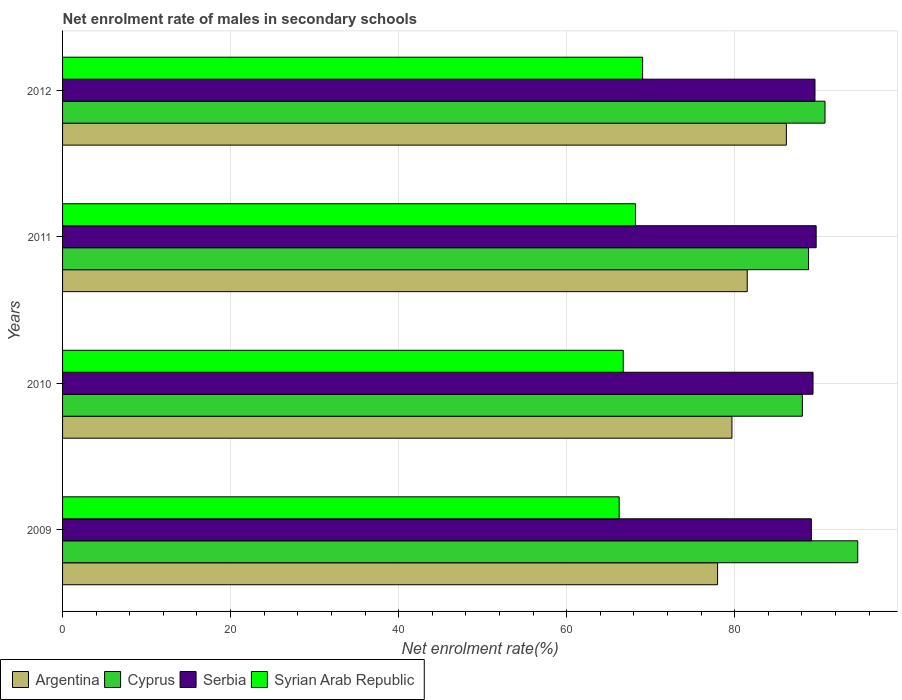Are the number of bars on each tick of the Y-axis equal?
Ensure brevity in your answer.  Yes. How many bars are there on the 1st tick from the top?
Offer a very short reply. 4. What is the net enrolment rate of males in secondary schools in Syrian Arab Republic in 2011?
Offer a terse response. 68.2. Across all years, what is the maximum net enrolment rate of males in secondary schools in Serbia?
Offer a terse response. 89.7. Across all years, what is the minimum net enrolment rate of males in secondary schools in Serbia?
Offer a terse response. 89.12. In which year was the net enrolment rate of males in secondary schools in Syrian Arab Republic maximum?
Ensure brevity in your answer.  2012. What is the total net enrolment rate of males in secondary schools in Syrian Arab Republic in the graph?
Offer a terse response. 270.22. What is the difference between the net enrolment rate of males in secondary schools in Argentina in 2011 and that in 2012?
Give a very brief answer. -4.66. What is the difference between the net enrolment rate of males in secondary schools in Cyprus in 2010 and the net enrolment rate of males in secondary schools in Serbia in 2009?
Give a very brief answer. -1.07. What is the average net enrolment rate of males in secondary schools in Cyprus per year?
Ensure brevity in your answer.  90.56. In the year 2009, what is the difference between the net enrolment rate of males in secondary schools in Argentina and net enrolment rate of males in secondary schools in Syrian Arab Republic?
Provide a succinct answer. 11.72. In how many years, is the net enrolment rate of males in secondary schools in Syrian Arab Republic greater than 84 %?
Your answer should be very brief. 0. What is the ratio of the net enrolment rate of males in secondary schools in Syrian Arab Republic in 2010 to that in 2011?
Provide a short and direct response. 0.98. Is the net enrolment rate of males in secondary schools in Cyprus in 2010 less than that in 2011?
Your response must be concise. Yes. What is the difference between the highest and the second highest net enrolment rate of males in secondary schools in Argentina?
Give a very brief answer. 4.66. What is the difference between the highest and the lowest net enrolment rate of males in secondary schools in Serbia?
Give a very brief answer. 0.57. Is the sum of the net enrolment rate of males in secondary schools in Serbia in 2009 and 2011 greater than the maximum net enrolment rate of males in secondary schools in Argentina across all years?
Keep it short and to the point. Yes. Is it the case that in every year, the sum of the net enrolment rate of males in secondary schools in Syrian Arab Republic and net enrolment rate of males in secondary schools in Cyprus is greater than the sum of net enrolment rate of males in secondary schools in Argentina and net enrolment rate of males in secondary schools in Serbia?
Your response must be concise. Yes. What does the 4th bar from the top in 2010 represents?
Make the answer very short. Argentina. What does the 1st bar from the bottom in 2011 represents?
Keep it short and to the point. Argentina. Is it the case that in every year, the sum of the net enrolment rate of males in secondary schools in Serbia and net enrolment rate of males in secondary schools in Syrian Arab Republic is greater than the net enrolment rate of males in secondary schools in Argentina?
Your answer should be compact. Yes. How many years are there in the graph?
Provide a short and direct response. 4. What is the difference between two consecutive major ticks on the X-axis?
Your answer should be compact. 20. Does the graph contain any zero values?
Ensure brevity in your answer.  No. Does the graph contain grids?
Keep it short and to the point. Yes. Where does the legend appear in the graph?
Your answer should be very brief. Bottom left. What is the title of the graph?
Offer a very short reply. Net enrolment rate of males in secondary schools. Does "France" appear as one of the legend labels in the graph?
Provide a succinct answer. No. What is the label or title of the X-axis?
Keep it short and to the point. Net enrolment rate(%). What is the label or title of the Y-axis?
Your response must be concise. Years. What is the Net enrolment rate(%) of Argentina in 2009?
Your answer should be very brief. 77.97. What is the Net enrolment rate(%) in Cyprus in 2009?
Keep it short and to the point. 94.65. What is the Net enrolment rate(%) of Serbia in 2009?
Your response must be concise. 89.12. What is the Net enrolment rate(%) of Syrian Arab Republic in 2009?
Your response must be concise. 66.25. What is the Net enrolment rate(%) of Argentina in 2010?
Your answer should be compact. 79.67. What is the Net enrolment rate(%) in Cyprus in 2010?
Keep it short and to the point. 88.05. What is the Net enrolment rate(%) of Serbia in 2010?
Keep it short and to the point. 89.32. What is the Net enrolment rate(%) of Syrian Arab Republic in 2010?
Offer a terse response. 66.74. What is the Net enrolment rate(%) in Argentina in 2011?
Offer a terse response. 81.49. What is the Net enrolment rate(%) of Cyprus in 2011?
Make the answer very short. 88.79. What is the Net enrolment rate(%) in Serbia in 2011?
Provide a succinct answer. 89.7. What is the Net enrolment rate(%) of Syrian Arab Republic in 2011?
Offer a very short reply. 68.2. What is the Net enrolment rate(%) in Argentina in 2012?
Your answer should be very brief. 86.15. What is the Net enrolment rate(%) in Cyprus in 2012?
Your response must be concise. 90.75. What is the Net enrolment rate(%) in Serbia in 2012?
Offer a terse response. 89.56. What is the Net enrolment rate(%) in Syrian Arab Republic in 2012?
Your response must be concise. 69.04. Across all years, what is the maximum Net enrolment rate(%) of Argentina?
Offer a terse response. 86.15. Across all years, what is the maximum Net enrolment rate(%) in Cyprus?
Ensure brevity in your answer.  94.65. Across all years, what is the maximum Net enrolment rate(%) in Serbia?
Provide a short and direct response. 89.7. Across all years, what is the maximum Net enrolment rate(%) in Syrian Arab Republic?
Offer a very short reply. 69.04. Across all years, what is the minimum Net enrolment rate(%) in Argentina?
Keep it short and to the point. 77.97. Across all years, what is the minimum Net enrolment rate(%) in Cyprus?
Offer a very short reply. 88.05. Across all years, what is the minimum Net enrolment rate(%) in Serbia?
Your answer should be very brief. 89.12. Across all years, what is the minimum Net enrolment rate(%) of Syrian Arab Republic?
Offer a very short reply. 66.25. What is the total Net enrolment rate(%) in Argentina in the graph?
Offer a terse response. 325.28. What is the total Net enrolment rate(%) in Cyprus in the graph?
Keep it short and to the point. 362.24. What is the total Net enrolment rate(%) in Serbia in the graph?
Make the answer very short. 357.7. What is the total Net enrolment rate(%) of Syrian Arab Republic in the graph?
Offer a very short reply. 270.22. What is the difference between the Net enrolment rate(%) in Argentina in 2009 and that in 2010?
Your response must be concise. -1.71. What is the difference between the Net enrolment rate(%) of Cyprus in 2009 and that in 2010?
Offer a terse response. 6.59. What is the difference between the Net enrolment rate(%) of Serbia in 2009 and that in 2010?
Your answer should be compact. -0.2. What is the difference between the Net enrolment rate(%) of Syrian Arab Republic in 2009 and that in 2010?
Your answer should be very brief. -0.49. What is the difference between the Net enrolment rate(%) in Argentina in 2009 and that in 2011?
Make the answer very short. -3.53. What is the difference between the Net enrolment rate(%) of Cyprus in 2009 and that in 2011?
Your response must be concise. 5.85. What is the difference between the Net enrolment rate(%) in Serbia in 2009 and that in 2011?
Provide a short and direct response. -0.57. What is the difference between the Net enrolment rate(%) in Syrian Arab Republic in 2009 and that in 2011?
Your answer should be very brief. -1.95. What is the difference between the Net enrolment rate(%) of Argentina in 2009 and that in 2012?
Offer a terse response. -8.19. What is the difference between the Net enrolment rate(%) of Cyprus in 2009 and that in 2012?
Your answer should be compact. 3.9. What is the difference between the Net enrolment rate(%) in Serbia in 2009 and that in 2012?
Offer a very short reply. -0.43. What is the difference between the Net enrolment rate(%) in Syrian Arab Republic in 2009 and that in 2012?
Provide a short and direct response. -2.79. What is the difference between the Net enrolment rate(%) of Argentina in 2010 and that in 2011?
Provide a short and direct response. -1.82. What is the difference between the Net enrolment rate(%) of Cyprus in 2010 and that in 2011?
Make the answer very short. -0.74. What is the difference between the Net enrolment rate(%) of Serbia in 2010 and that in 2011?
Your answer should be compact. -0.37. What is the difference between the Net enrolment rate(%) in Syrian Arab Republic in 2010 and that in 2011?
Your answer should be very brief. -1.46. What is the difference between the Net enrolment rate(%) of Argentina in 2010 and that in 2012?
Provide a short and direct response. -6.48. What is the difference between the Net enrolment rate(%) of Cyprus in 2010 and that in 2012?
Your response must be concise. -2.7. What is the difference between the Net enrolment rate(%) of Serbia in 2010 and that in 2012?
Your answer should be compact. -0.23. What is the difference between the Net enrolment rate(%) in Syrian Arab Republic in 2010 and that in 2012?
Your response must be concise. -2.3. What is the difference between the Net enrolment rate(%) in Argentina in 2011 and that in 2012?
Your answer should be very brief. -4.66. What is the difference between the Net enrolment rate(%) in Cyprus in 2011 and that in 2012?
Provide a succinct answer. -1.96. What is the difference between the Net enrolment rate(%) of Serbia in 2011 and that in 2012?
Make the answer very short. 0.14. What is the difference between the Net enrolment rate(%) in Syrian Arab Republic in 2011 and that in 2012?
Your response must be concise. -0.84. What is the difference between the Net enrolment rate(%) in Argentina in 2009 and the Net enrolment rate(%) in Cyprus in 2010?
Offer a very short reply. -10.09. What is the difference between the Net enrolment rate(%) in Argentina in 2009 and the Net enrolment rate(%) in Serbia in 2010?
Keep it short and to the point. -11.36. What is the difference between the Net enrolment rate(%) in Argentina in 2009 and the Net enrolment rate(%) in Syrian Arab Republic in 2010?
Give a very brief answer. 11.23. What is the difference between the Net enrolment rate(%) in Cyprus in 2009 and the Net enrolment rate(%) in Serbia in 2010?
Your answer should be very brief. 5.32. What is the difference between the Net enrolment rate(%) of Cyprus in 2009 and the Net enrolment rate(%) of Syrian Arab Republic in 2010?
Provide a short and direct response. 27.91. What is the difference between the Net enrolment rate(%) of Serbia in 2009 and the Net enrolment rate(%) of Syrian Arab Republic in 2010?
Ensure brevity in your answer.  22.39. What is the difference between the Net enrolment rate(%) in Argentina in 2009 and the Net enrolment rate(%) in Cyprus in 2011?
Ensure brevity in your answer.  -10.83. What is the difference between the Net enrolment rate(%) of Argentina in 2009 and the Net enrolment rate(%) of Serbia in 2011?
Provide a succinct answer. -11.73. What is the difference between the Net enrolment rate(%) of Argentina in 2009 and the Net enrolment rate(%) of Syrian Arab Republic in 2011?
Provide a succinct answer. 9.77. What is the difference between the Net enrolment rate(%) in Cyprus in 2009 and the Net enrolment rate(%) in Serbia in 2011?
Ensure brevity in your answer.  4.95. What is the difference between the Net enrolment rate(%) of Cyprus in 2009 and the Net enrolment rate(%) of Syrian Arab Republic in 2011?
Offer a terse response. 26.45. What is the difference between the Net enrolment rate(%) in Serbia in 2009 and the Net enrolment rate(%) in Syrian Arab Republic in 2011?
Offer a very short reply. 20.93. What is the difference between the Net enrolment rate(%) in Argentina in 2009 and the Net enrolment rate(%) in Cyprus in 2012?
Give a very brief answer. -12.78. What is the difference between the Net enrolment rate(%) of Argentina in 2009 and the Net enrolment rate(%) of Serbia in 2012?
Your answer should be very brief. -11.59. What is the difference between the Net enrolment rate(%) in Argentina in 2009 and the Net enrolment rate(%) in Syrian Arab Republic in 2012?
Provide a short and direct response. 8.92. What is the difference between the Net enrolment rate(%) in Cyprus in 2009 and the Net enrolment rate(%) in Serbia in 2012?
Keep it short and to the point. 5.09. What is the difference between the Net enrolment rate(%) of Cyprus in 2009 and the Net enrolment rate(%) of Syrian Arab Republic in 2012?
Provide a short and direct response. 25.6. What is the difference between the Net enrolment rate(%) in Serbia in 2009 and the Net enrolment rate(%) in Syrian Arab Republic in 2012?
Give a very brief answer. 20.08. What is the difference between the Net enrolment rate(%) of Argentina in 2010 and the Net enrolment rate(%) of Cyprus in 2011?
Offer a very short reply. -9.12. What is the difference between the Net enrolment rate(%) of Argentina in 2010 and the Net enrolment rate(%) of Serbia in 2011?
Ensure brevity in your answer.  -10.03. What is the difference between the Net enrolment rate(%) of Argentina in 2010 and the Net enrolment rate(%) of Syrian Arab Republic in 2011?
Offer a terse response. 11.47. What is the difference between the Net enrolment rate(%) in Cyprus in 2010 and the Net enrolment rate(%) in Serbia in 2011?
Give a very brief answer. -1.64. What is the difference between the Net enrolment rate(%) of Cyprus in 2010 and the Net enrolment rate(%) of Syrian Arab Republic in 2011?
Keep it short and to the point. 19.86. What is the difference between the Net enrolment rate(%) in Serbia in 2010 and the Net enrolment rate(%) in Syrian Arab Republic in 2011?
Keep it short and to the point. 21.13. What is the difference between the Net enrolment rate(%) in Argentina in 2010 and the Net enrolment rate(%) in Cyprus in 2012?
Provide a short and direct response. -11.08. What is the difference between the Net enrolment rate(%) in Argentina in 2010 and the Net enrolment rate(%) in Serbia in 2012?
Ensure brevity in your answer.  -9.89. What is the difference between the Net enrolment rate(%) of Argentina in 2010 and the Net enrolment rate(%) of Syrian Arab Republic in 2012?
Ensure brevity in your answer.  10.63. What is the difference between the Net enrolment rate(%) of Cyprus in 2010 and the Net enrolment rate(%) of Serbia in 2012?
Make the answer very short. -1.5. What is the difference between the Net enrolment rate(%) of Cyprus in 2010 and the Net enrolment rate(%) of Syrian Arab Republic in 2012?
Offer a very short reply. 19.01. What is the difference between the Net enrolment rate(%) in Serbia in 2010 and the Net enrolment rate(%) in Syrian Arab Republic in 2012?
Make the answer very short. 20.28. What is the difference between the Net enrolment rate(%) of Argentina in 2011 and the Net enrolment rate(%) of Cyprus in 2012?
Keep it short and to the point. -9.26. What is the difference between the Net enrolment rate(%) of Argentina in 2011 and the Net enrolment rate(%) of Serbia in 2012?
Your response must be concise. -8.06. What is the difference between the Net enrolment rate(%) in Argentina in 2011 and the Net enrolment rate(%) in Syrian Arab Republic in 2012?
Keep it short and to the point. 12.45. What is the difference between the Net enrolment rate(%) in Cyprus in 2011 and the Net enrolment rate(%) in Serbia in 2012?
Your response must be concise. -0.77. What is the difference between the Net enrolment rate(%) in Cyprus in 2011 and the Net enrolment rate(%) in Syrian Arab Republic in 2012?
Give a very brief answer. 19.75. What is the difference between the Net enrolment rate(%) of Serbia in 2011 and the Net enrolment rate(%) of Syrian Arab Republic in 2012?
Your answer should be compact. 20.66. What is the average Net enrolment rate(%) in Argentina per year?
Make the answer very short. 81.32. What is the average Net enrolment rate(%) in Cyprus per year?
Give a very brief answer. 90.56. What is the average Net enrolment rate(%) of Serbia per year?
Provide a succinct answer. 89.43. What is the average Net enrolment rate(%) in Syrian Arab Republic per year?
Offer a very short reply. 67.56. In the year 2009, what is the difference between the Net enrolment rate(%) of Argentina and Net enrolment rate(%) of Cyprus?
Your response must be concise. -16.68. In the year 2009, what is the difference between the Net enrolment rate(%) of Argentina and Net enrolment rate(%) of Serbia?
Keep it short and to the point. -11.16. In the year 2009, what is the difference between the Net enrolment rate(%) in Argentina and Net enrolment rate(%) in Syrian Arab Republic?
Ensure brevity in your answer.  11.72. In the year 2009, what is the difference between the Net enrolment rate(%) in Cyprus and Net enrolment rate(%) in Serbia?
Offer a very short reply. 5.52. In the year 2009, what is the difference between the Net enrolment rate(%) of Cyprus and Net enrolment rate(%) of Syrian Arab Republic?
Your answer should be very brief. 28.4. In the year 2009, what is the difference between the Net enrolment rate(%) in Serbia and Net enrolment rate(%) in Syrian Arab Republic?
Your answer should be compact. 22.87. In the year 2010, what is the difference between the Net enrolment rate(%) in Argentina and Net enrolment rate(%) in Cyprus?
Keep it short and to the point. -8.38. In the year 2010, what is the difference between the Net enrolment rate(%) of Argentina and Net enrolment rate(%) of Serbia?
Offer a very short reply. -9.65. In the year 2010, what is the difference between the Net enrolment rate(%) of Argentina and Net enrolment rate(%) of Syrian Arab Republic?
Provide a succinct answer. 12.94. In the year 2010, what is the difference between the Net enrolment rate(%) of Cyprus and Net enrolment rate(%) of Serbia?
Your answer should be compact. -1.27. In the year 2010, what is the difference between the Net enrolment rate(%) of Cyprus and Net enrolment rate(%) of Syrian Arab Republic?
Make the answer very short. 21.32. In the year 2010, what is the difference between the Net enrolment rate(%) of Serbia and Net enrolment rate(%) of Syrian Arab Republic?
Your answer should be compact. 22.59. In the year 2011, what is the difference between the Net enrolment rate(%) of Argentina and Net enrolment rate(%) of Cyprus?
Keep it short and to the point. -7.3. In the year 2011, what is the difference between the Net enrolment rate(%) in Argentina and Net enrolment rate(%) in Serbia?
Keep it short and to the point. -8.2. In the year 2011, what is the difference between the Net enrolment rate(%) in Argentina and Net enrolment rate(%) in Syrian Arab Republic?
Ensure brevity in your answer.  13.3. In the year 2011, what is the difference between the Net enrolment rate(%) of Cyprus and Net enrolment rate(%) of Serbia?
Provide a succinct answer. -0.91. In the year 2011, what is the difference between the Net enrolment rate(%) in Cyprus and Net enrolment rate(%) in Syrian Arab Republic?
Provide a succinct answer. 20.59. In the year 2011, what is the difference between the Net enrolment rate(%) of Serbia and Net enrolment rate(%) of Syrian Arab Republic?
Your response must be concise. 21.5. In the year 2012, what is the difference between the Net enrolment rate(%) in Argentina and Net enrolment rate(%) in Cyprus?
Your answer should be compact. -4.6. In the year 2012, what is the difference between the Net enrolment rate(%) of Argentina and Net enrolment rate(%) of Serbia?
Keep it short and to the point. -3.41. In the year 2012, what is the difference between the Net enrolment rate(%) of Argentina and Net enrolment rate(%) of Syrian Arab Republic?
Make the answer very short. 17.11. In the year 2012, what is the difference between the Net enrolment rate(%) in Cyprus and Net enrolment rate(%) in Serbia?
Give a very brief answer. 1.19. In the year 2012, what is the difference between the Net enrolment rate(%) in Cyprus and Net enrolment rate(%) in Syrian Arab Republic?
Offer a terse response. 21.71. In the year 2012, what is the difference between the Net enrolment rate(%) in Serbia and Net enrolment rate(%) in Syrian Arab Republic?
Provide a short and direct response. 20.52. What is the ratio of the Net enrolment rate(%) in Argentina in 2009 to that in 2010?
Provide a succinct answer. 0.98. What is the ratio of the Net enrolment rate(%) in Cyprus in 2009 to that in 2010?
Provide a short and direct response. 1.07. What is the ratio of the Net enrolment rate(%) in Serbia in 2009 to that in 2010?
Make the answer very short. 1. What is the ratio of the Net enrolment rate(%) in Argentina in 2009 to that in 2011?
Keep it short and to the point. 0.96. What is the ratio of the Net enrolment rate(%) of Cyprus in 2009 to that in 2011?
Offer a very short reply. 1.07. What is the ratio of the Net enrolment rate(%) of Syrian Arab Republic in 2009 to that in 2011?
Your response must be concise. 0.97. What is the ratio of the Net enrolment rate(%) in Argentina in 2009 to that in 2012?
Offer a terse response. 0.91. What is the ratio of the Net enrolment rate(%) in Cyprus in 2009 to that in 2012?
Offer a terse response. 1.04. What is the ratio of the Net enrolment rate(%) of Syrian Arab Republic in 2009 to that in 2012?
Offer a very short reply. 0.96. What is the ratio of the Net enrolment rate(%) of Argentina in 2010 to that in 2011?
Keep it short and to the point. 0.98. What is the ratio of the Net enrolment rate(%) in Serbia in 2010 to that in 2011?
Give a very brief answer. 1. What is the ratio of the Net enrolment rate(%) in Syrian Arab Republic in 2010 to that in 2011?
Keep it short and to the point. 0.98. What is the ratio of the Net enrolment rate(%) of Argentina in 2010 to that in 2012?
Your response must be concise. 0.92. What is the ratio of the Net enrolment rate(%) of Cyprus in 2010 to that in 2012?
Offer a very short reply. 0.97. What is the ratio of the Net enrolment rate(%) in Syrian Arab Republic in 2010 to that in 2012?
Your response must be concise. 0.97. What is the ratio of the Net enrolment rate(%) of Argentina in 2011 to that in 2012?
Offer a terse response. 0.95. What is the ratio of the Net enrolment rate(%) of Cyprus in 2011 to that in 2012?
Your answer should be compact. 0.98. What is the ratio of the Net enrolment rate(%) of Syrian Arab Republic in 2011 to that in 2012?
Offer a very short reply. 0.99. What is the difference between the highest and the second highest Net enrolment rate(%) of Argentina?
Provide a short and direct response. 4.66. What is the difference between the highest and the second highest Net enrolment rate(%) of Cyprus?
Ensure brevity in your answer.  3.9. What is the difference between the highest and the second highest Net enrolment rate(%) of Serbia?
Give a very brief answer. 0.14. What is the difference between the highest and the second highest Net enrolment rate(%) in Syrian Arab Republic?
Your response must be concise. 0.84. What is the difference between the highest and the lowest Net enrolment rate(%) in Argentina?
Keep it short and to the point. 8.19. What is the difference between the highest and the lowest Net enrolment rate(%) of Cyprus?
Give a very brief answer. 6.59. What is the difference between the highest and the lowest Net enrolment rate(%) of Serbia?
Keep it short and to the point. 0.57. What is the difference between the highest and the lowest Net enrolment rate(%) of Syrian Arab Republic?
Provide a succinct answer. 2.79. 